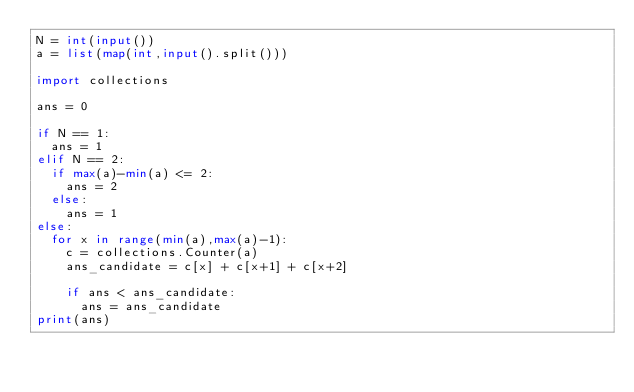<code> <loc_0><loc_0><loc_500><loc_500><_Python_>N = int(input())
a = list(map(int,input().split()))

import collections

ans = 0

if N == 1:
  ans = 1
elif N == 2:
  if max(a)-min(a) <= 2:
    ans = 2
  else:
    ans = 1
else:
  for x in range(min(a),max(a)-1):
    c = collections.Counter(a)
    ans_candidate = c[x] + c[x+1] + c[x+2]

    if ans < ans_candidate:
      ans = ans_candidate
print(ans)
</code> 